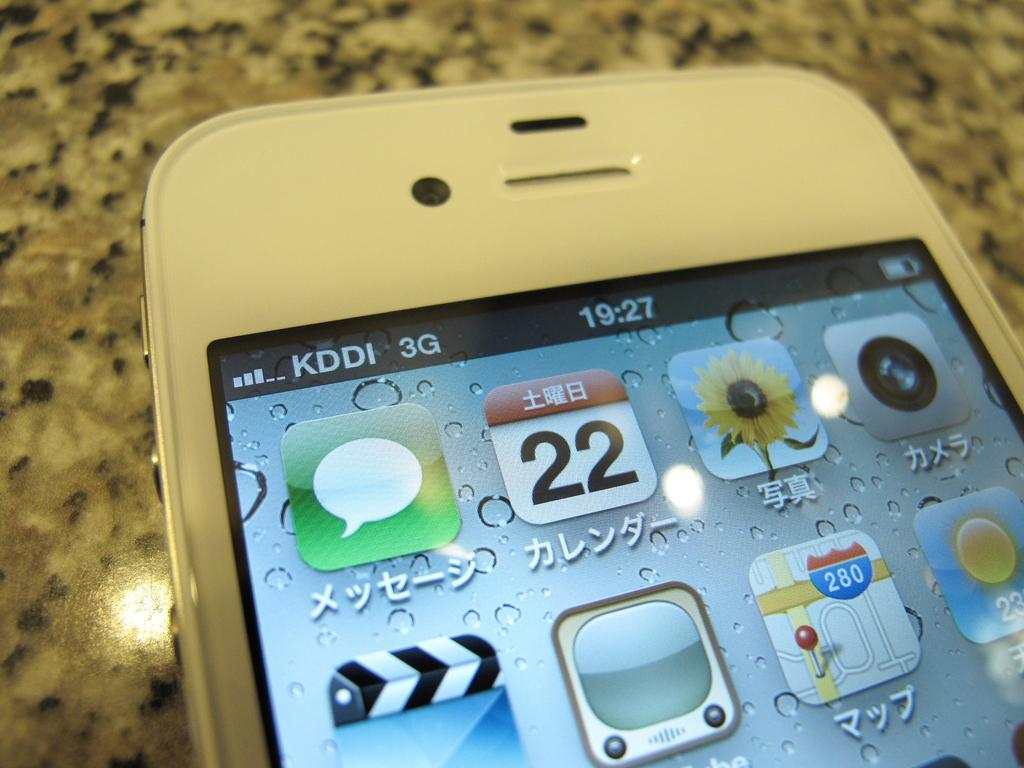<image>
Share a concise interpretation of the image provided. the image of a phone written in japanese on the 22 day of the month 